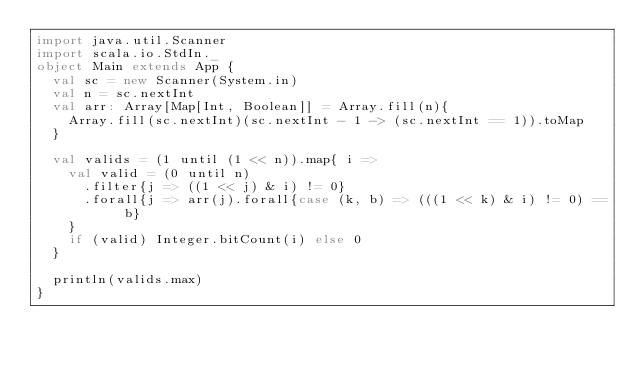<code> <loc_0><loc_0><loc_500><loc_500><_Scala_>import java.util.Scanner
import scala.io.StdIn._
object Main extends App {
  val sc = new Scanner(System.in)
  val n = sc.nextInt
  val arr: Array[Map[Int, Boolean]] = Array.fill(n){
    Array.fill(sc.nextInt)(sc.nextInt - 1 -> (sc.nextInt == 1)).toMap
  }
 
  val valids = (1 until (1 << n)).map{ i =>
    val valid = (0 until n)
      .filter{j => ((1 << j) & i) != 0}
      .forall{j => arr(j).forall{case (k, b) => (((1 << k) & i) != 0) == b}
    }
    if (valid) Integer.bitCount(i) else 0
  }
 
  println(valids.max)
}</code> 